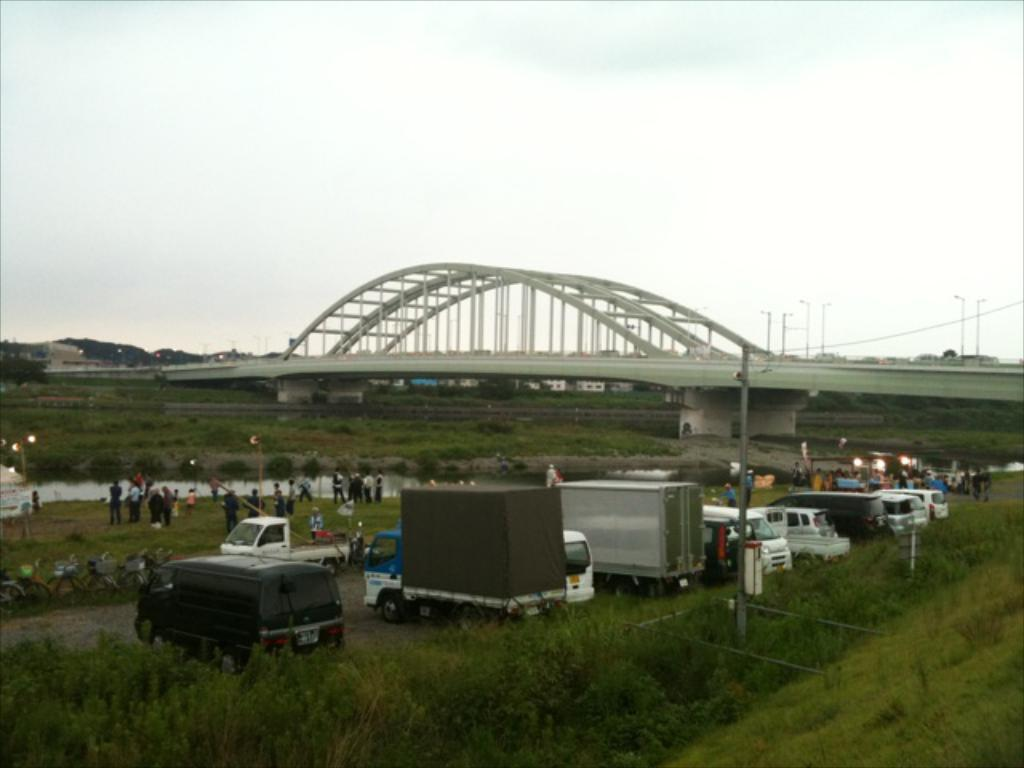What is the main setting of the image? The main setting of the image is a group of people on the grass. What else can be seen in the image besides the group of people? There are vehicles on the road, plants, poles, a bridge, and some unspecified objects in the image. What is visible in the background of the image? The sky is visible in the background of the image. Can you describe the rabbits playing in the picture? There are no rabbits present in the image; it features a group of people on the grass, vehicles, plants, poles, a bridge, and unspecified objects. How does the stranger interact with the group of people in the image? There is no stranger present in the image; it features a group of people on the grass, vehicles, plants, poles, a bridge, and unspecified objects. 